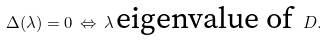Convert formula to latex. <formula><loc_0><loc_0><loc_500><loc_500>\Delta ( \lambda ) = 0 \, \Leftrightarrow \, \lambda \, \text {eigenvalue of } \, D .</formula> 